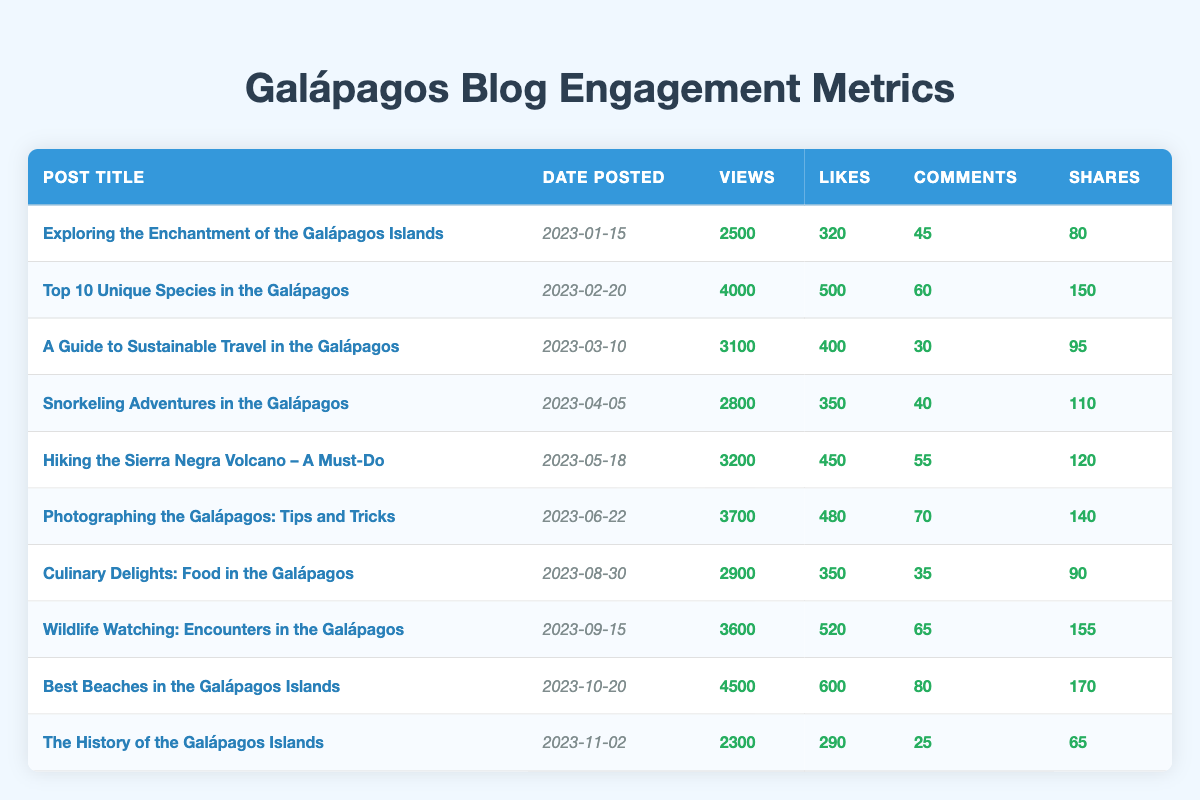What is the post with the highest number of views? The table shows the views for each blog post, and "Best Beaches in the Galápagos Islands" has the highest number of views at 4500.
Answer: Best Beaches in the Galápagos Islands How many likes did "Snorkeling Adventures in the Galápagos" receive? The table indicates that "Snorkeling Adventures in the Galápagos" received 350 likes.
Answer: 350 What is the total number of shares for all posts combined? To find the total shares, we add up the shares from each post: 80 + 150 + 95 + 110 + 120 + 140 + 90 + 155 + 170 + 65 = 1,120.
Answer: 1120 Which month had the highest engagement in terms of likes? By reviewing the likes, "Best Beaches in the Galápagos Islands" in October had the highest likes at 600, thus indicating October had the highest engagement.
Answer: October Is there a post that received more than 500 likes? The table shows that no post received more than 600 likes; hence, the answer is no.
Answer: No What is the average number of views for the posts posted in March and April? The views for March and April are 3100 and 2800, respectively. To find the average, we add them: 3100 + 2800 = 5900, then divide by 2, yielding an average of 2950.
Answer: 2950 Which post had the lowest number of comments? By checking the comments column, "The History of the Galápagos Islands" received the fewest comments, which is 25.
Answer: The History of the Galápagos Islands How many more views did "Top 10 Unique Species in the Galápagos" have than "Culinary Delights: Food in the Galápagos"? The views for "Top 10 Unique Species in the Galápagos" are 4000 and for "Culinary Delights" are 2900. The difference is 4000 - 2900 = 1100.
Answer: 1100 What percentage of views did "Photographing the Galápagos: Tips and Tricks" have compared to the post with the most views? "Photographing the Galápagos: Tips and Tricks" has 3700 views compared to the max views (4500). The percentage is (3700/4500) * 100 = 82.22%.
Answer: 82.22% Are there more posts with over 3000 views or under? There are 6 posts with over 3000 views (from "Top 10 Unique Species in the Galápagos" to "Best Beaches in the Galápagos Islands") and 4 posts under 3000 views. Hence, more posts have over 3000 views.
Answer: More posts over 3000 views 